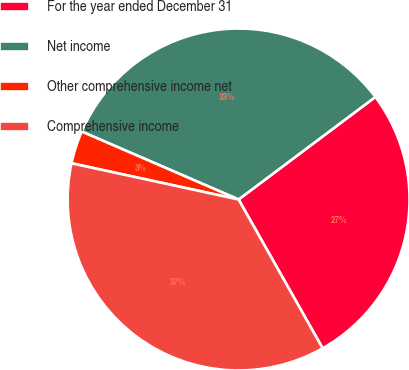<chart> <loc_0><loc_0><loc_500><loc_500><pie_chart><fcel>For the year ended December 31<fcel>Net income<fcel>Other comprehensive income net<fcel>Comprehensive income<nl><fcel>27.06%<fcel>33.26%<fcel>3.11%<fcel>36.58%<nl></chart> 